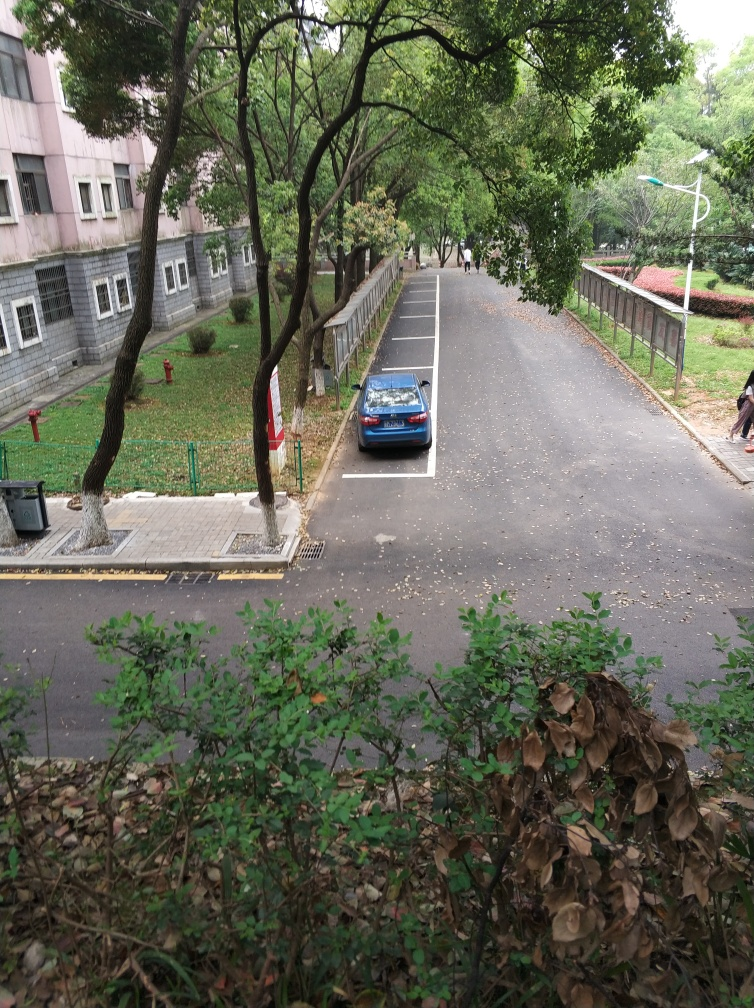What time of year does this image seem to depict? The image suggests that it might be late autumn due to the presence of fallen leaves and the mixture of green and brown foliage. 